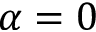<formula> <loc_0><loc_0><loc_500><loc_500>\alpha = 0</formula> 